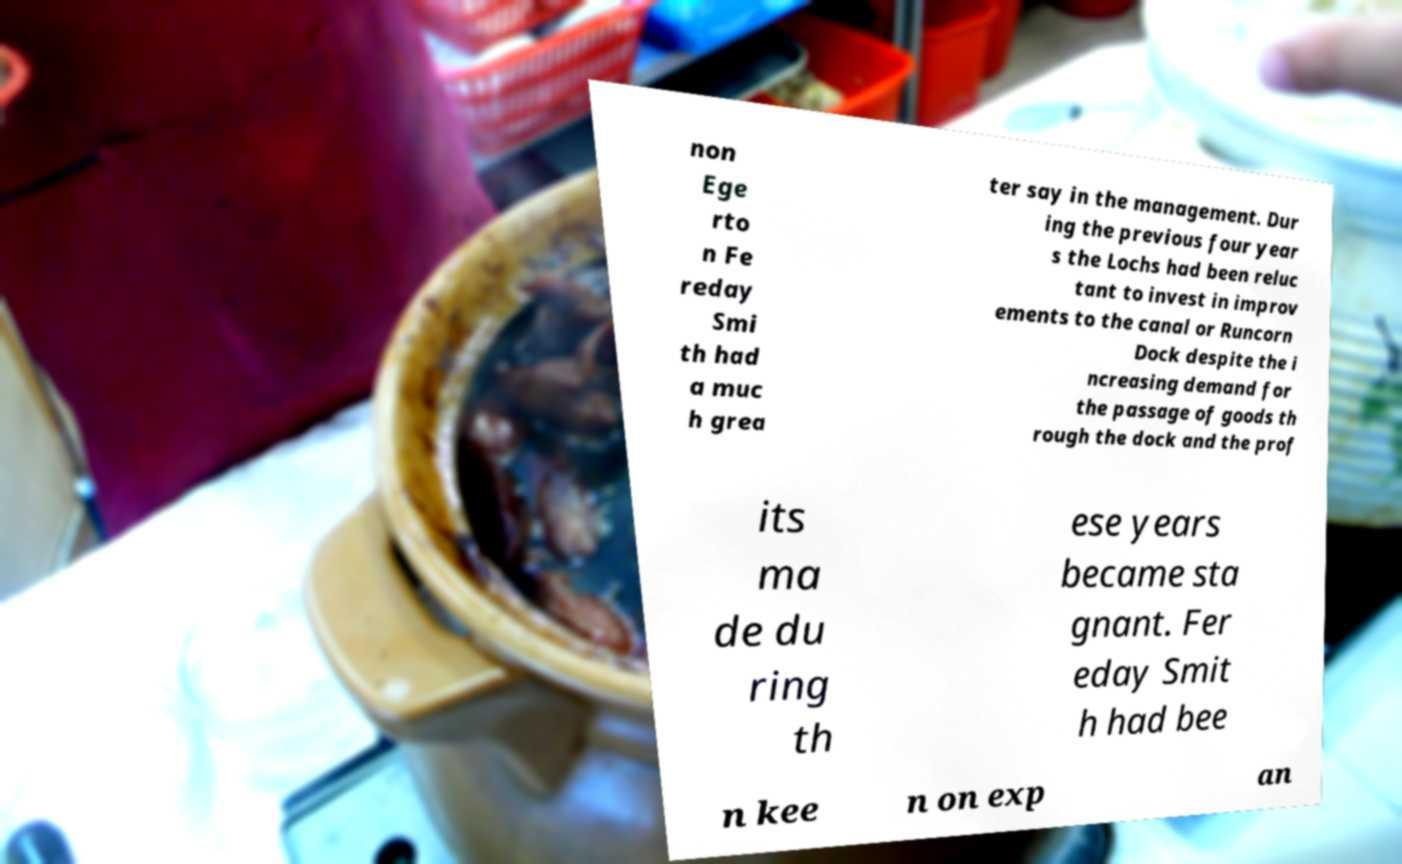Please identify and transcribe the text found in this image. non Ege rto n Fe reday Smi th had a muc h grea ter say in the management. Dur ing the previous four year s the Lochs had been reluc tant to invest in improv ements to the canal or Runcorn Dock despite the i ncreasing demand for the passage of goods th rough the dock and the prof its ma de du ring th ese years became sta gnant. Fer eday Smit h had bee n kee n on exp an 